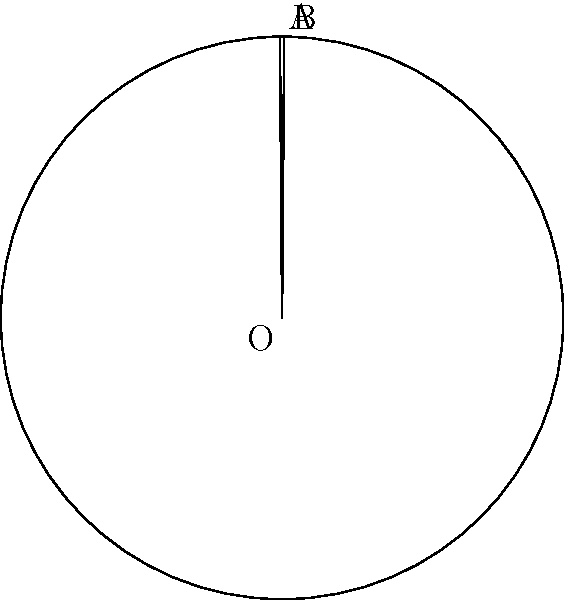In a circular gene expression pattern, a chord AB with length 2.5 units is observed in a circle with radius 3 units. Calculate the area of the circular segment cut off by this chord. Express your answer in terms of π and round to two decimal places. To calculate the area of the circular segment, we'll follow these steps:

1) First, we need to find the central angle θ subtended by the chord:
   $\sin(\frac{\theta}{2}) = \frac{c}{2r}$, where c is the chord length and r is the radius
   $\frac{\theta}{2} = \arcsin(\frac{2.5}{2 \cdot 3}) = \arcsin(\frac{5}{12})$
   $\theta = 2 \arcsin(\frac{5}{12})$ radians

2) The area of a circular segment is given by the formula:
   $A = r^2 \arccos(\frac{r-h}{r}) - (r-h)\sqrt{2rh-h^2}$
   where h is the height of the segment

3) We can simplify this using the central angle:
   $A = \frac{1}{2}r^2(\theta - \sin\theta)$

4) Substituting our values:
   $A = \frac{1}{2} \cdot 3^2 (2\arcsin(\frac{5}{12}) - \sin(2\arcsin(\frac{5}{12})))$

5) Simplify:
   $A = \frac{9}{2} (2\arcsin(\frac{5}{12}) - \sin(2\arcsin(\frac{5}{12})))$

6) Using the double angle formula for sine:
   $\sin(2\arcsin(x)) = 2x\sqrt{1-x^2}$

7) Substitute $x = \frac{5}{12}$:
   $A = \frac{9}{2} (2\arcsin(\frac{5}{12}) - 2\cdot\frac{5}{12}\sqrt{1-(\frac{5}{12})^2})$
   $= \frac{9}{2} (2\arcsin(\frac{5}{12}) - \frac{5}{6}\sqrt{\frac{119}{144}})$

8) Evaluate:
   $A \approx 1.40\pi$ square units (rounded to two decimal places)
Answer: $1.40\pi$ square units 